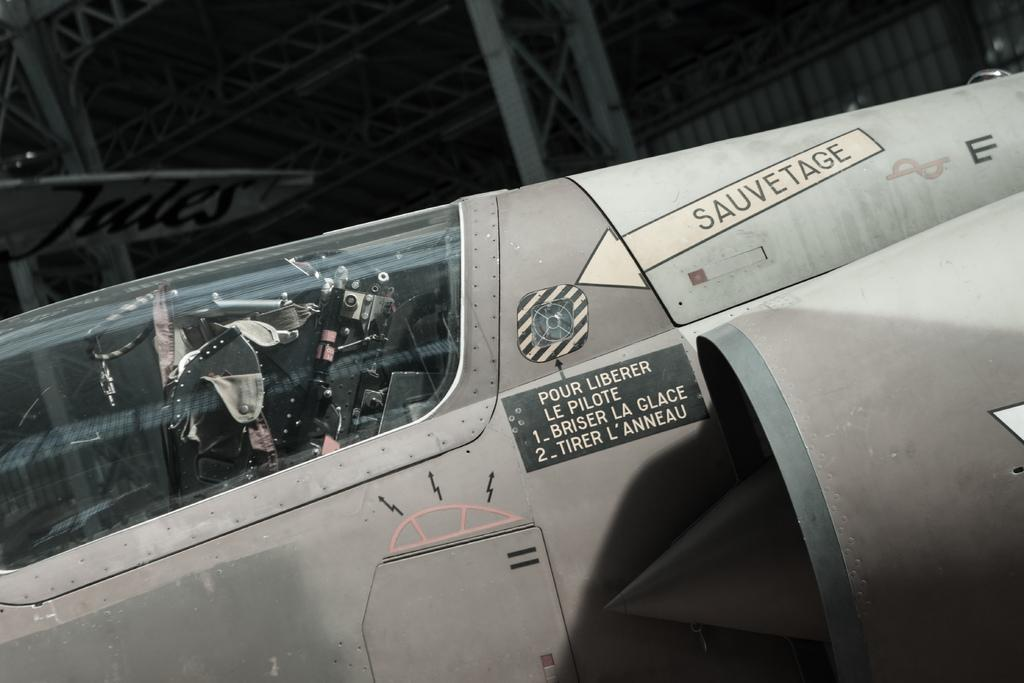What is the main subject of the picture? The main subject of the picture is an airplane. What is the color of the airplane? The airplane is grey in color. Are there any markings or text on the airplane? Yes, there is text written on the airplane. What can be seen in the background of the picture? There is a pillar visible in the background. How would you describe the lighting or color of the background? The background is dark. How many buns are being attacked by the ladybug in the image? There are no buns or ladybugs present in the image; it features an airplane with text and a dark background. 